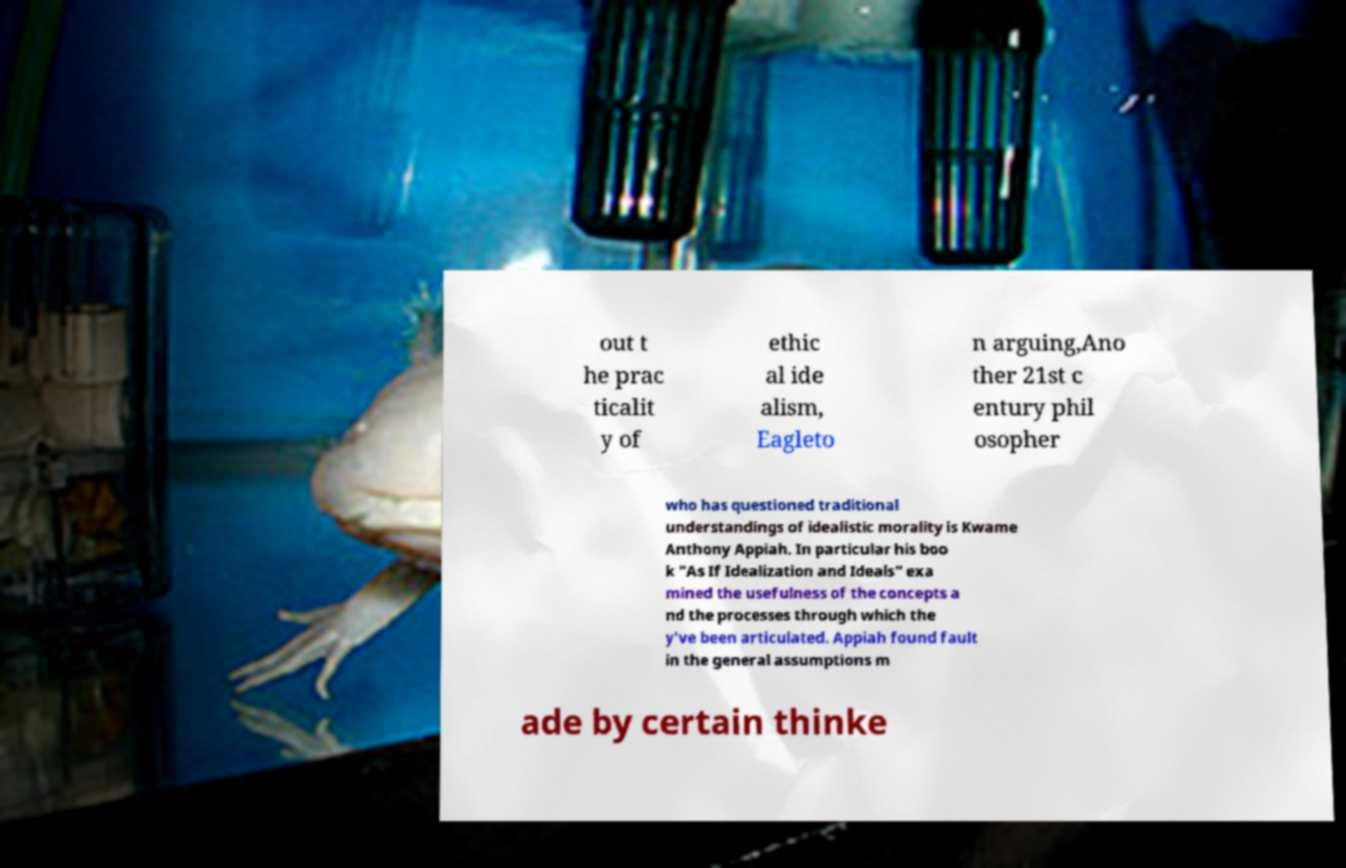Please identify and transcribe the text found in this image. out t he prac ticalit y of ethic al ide alism, Eagleto n arguing,Ano ther 21st c entury phil osopher who has questioned traditional understandings of idealistic morality is Kwame Anthony Appiah. In particular his boo k "As If Idealization and Ideals" exa mined the usefulness of the concepts a nd the processes through which the y've been articulated. Appiah found fault in the general assumptions m ade by certain thinke 